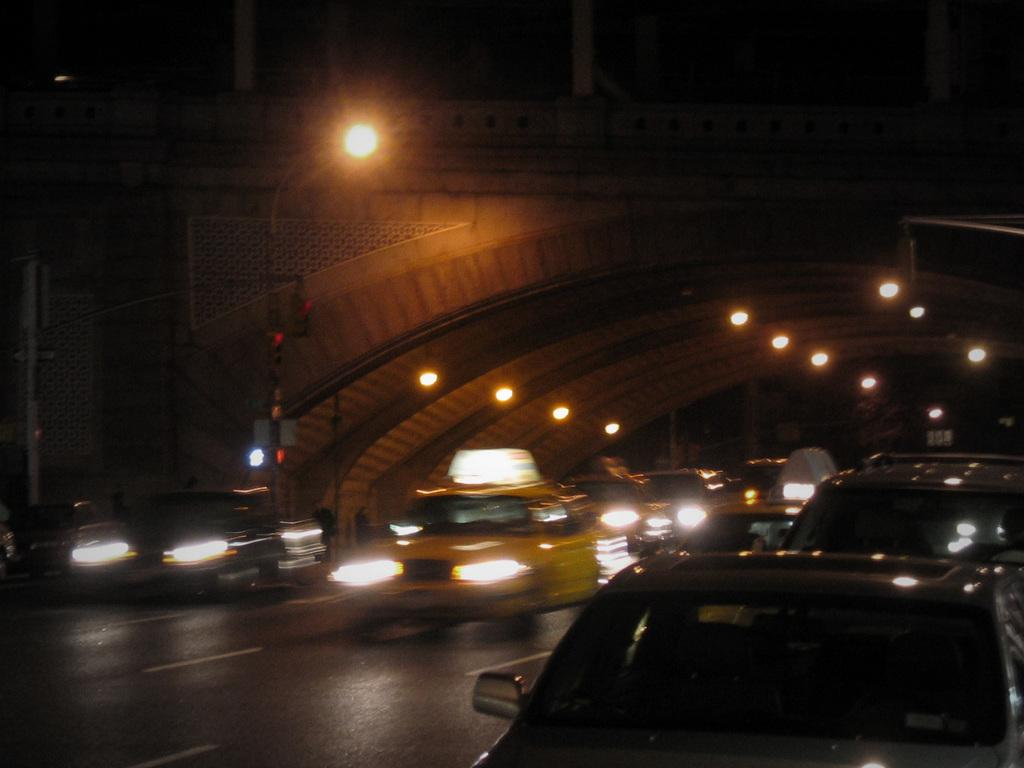What is happening on the road in the image? There are cars moving on the road in the image. What can be seen in the background of the image? There is a bridge and a pole in the backdrop of the image. What type of glove is the coach wearing while talking to the owner in the image? There is no glove, coach, or owner present in the image. 